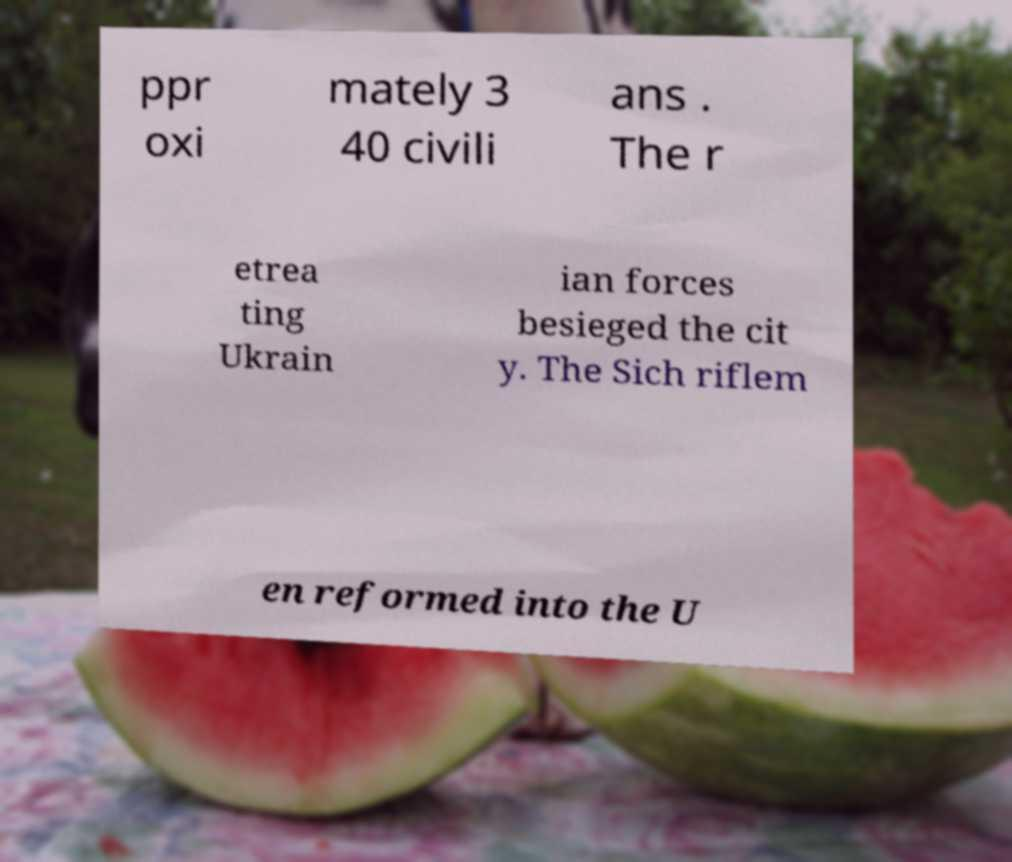What messages or text are displayed in this image? I need them in a readable, typed format. ppr oxi mately 3 40 civili ans . The r etrea ting Ukrain ian forces besieged the cit y. The Sich riflem en reformed into the U 